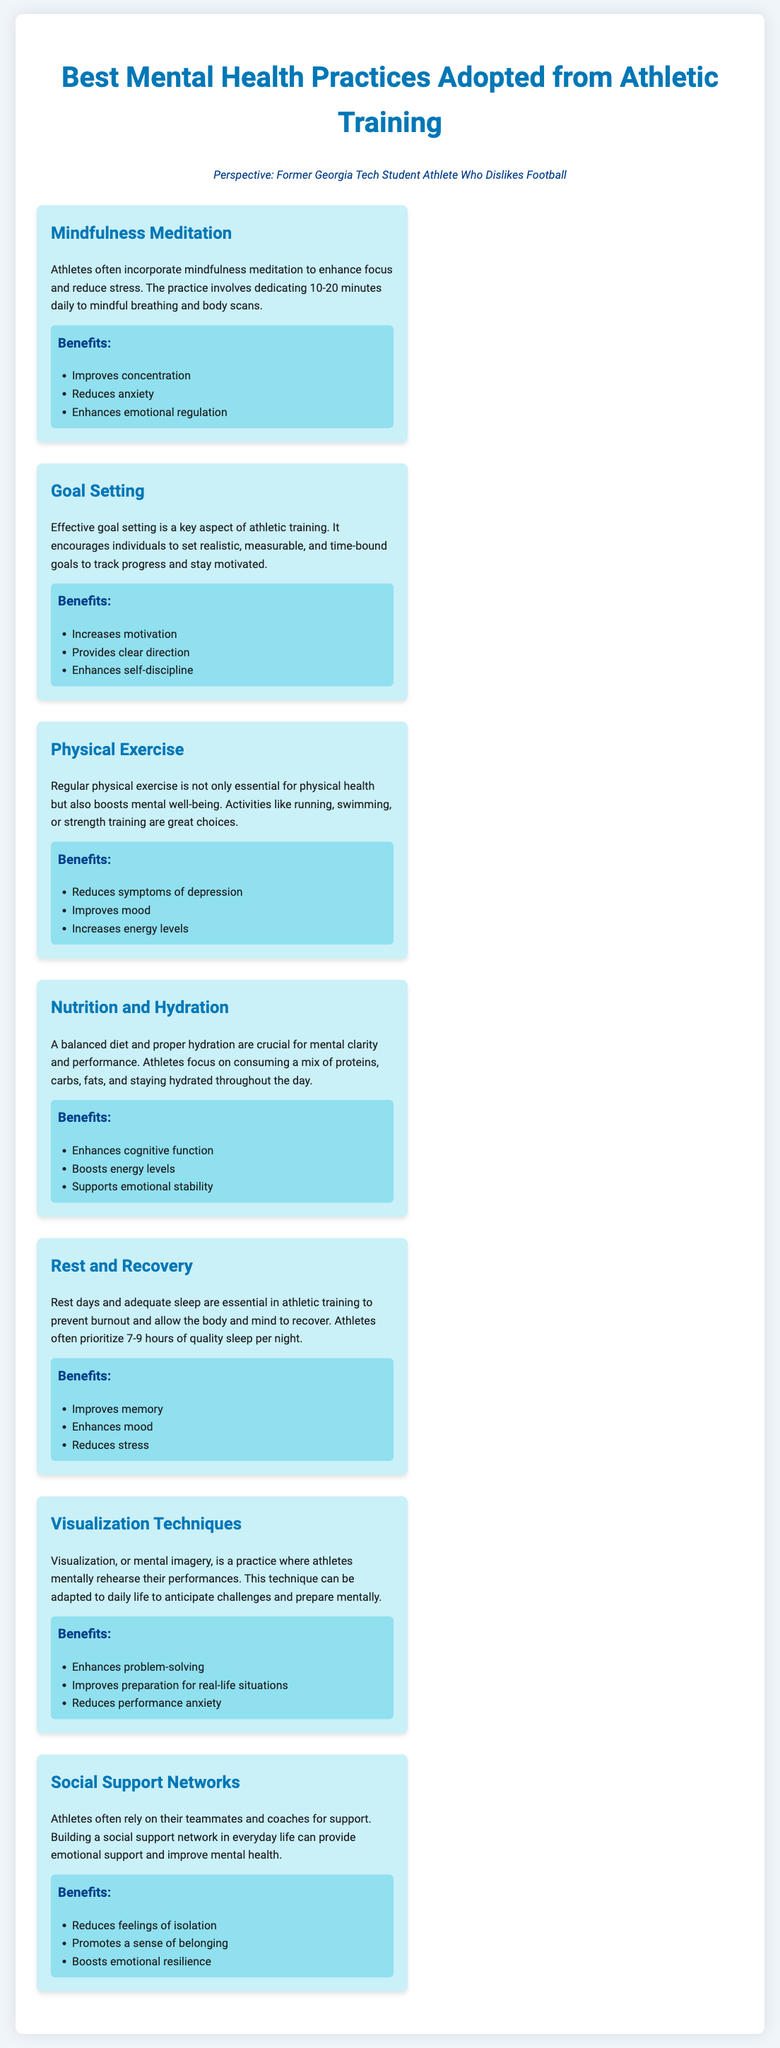What is the title of the document? The title is stated clearly at the top of the document, summarizing its main focus.
Answer: Best Mental Health Practices from Athletic Training How many practices are listed in the document? The document contains a total of seven distinct practices related to mental health from athletic training.
Answer: 7 What is one benefit of mindfulness meditation? The document lists specific benefits associated with each practice; one of them for mindfulness meditation is listed.
Answer: Improves concentration What practice focuses on nutrition and hydration? The document explicitly mentions the importance of diet and hydration as a separate practice contributing to mental wellness.
Answer: Nutrition and Hydration How many hours of sleep do athletes prioritize according to the document? The document specifies recommended sleep duration for athletes to recover effectively.
Answer: 7-9 hours What does visualization techniques help to reduce? This practice is highlighted in the document along with its benefits, specifically mentioning performance anxiety as one of them.
Answer: Performance anxiety What is a key aspect of effective goal setting? The document indicates that goal setting includes certain criteria to make it beneficial for athletes and others.
Answer: Realistic and measurable Which practice emphasizes the importance of social interactions? The document identifies a specific practice focusing on support from others as essential for mental health.
Answer: Social Support Networks 